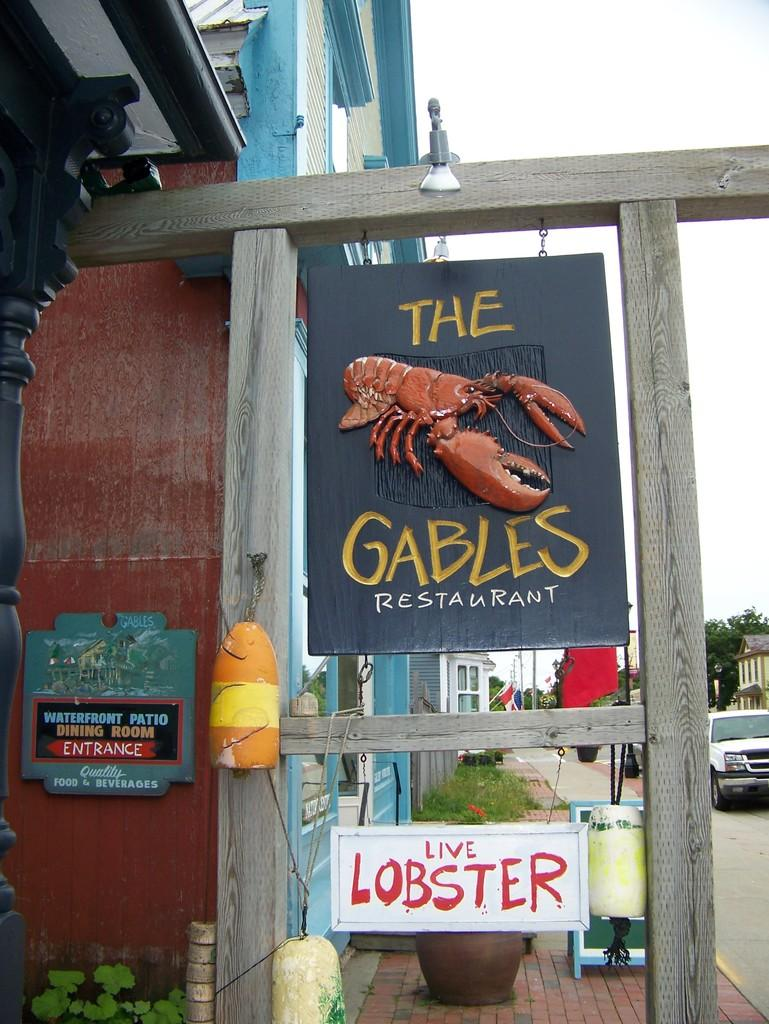How many boards can be seen in the image? There are two boards in the image. What is written or depicted on the boards? Text is visible on the boards. What celestial bodies are depicted in the image? Planets are depicted in the image. What type of vehicle is present in the image? A vehicle is present in the image. What type of vegetation is visible in the image? Trees are visible in the image. Can you see a snake slithering through the trees in the image? There is no snake present in the image; only trees are visible. Is there a deer hiding behind the vehicle in the image? There is no deer present in the image; only a vehicle is visible. 